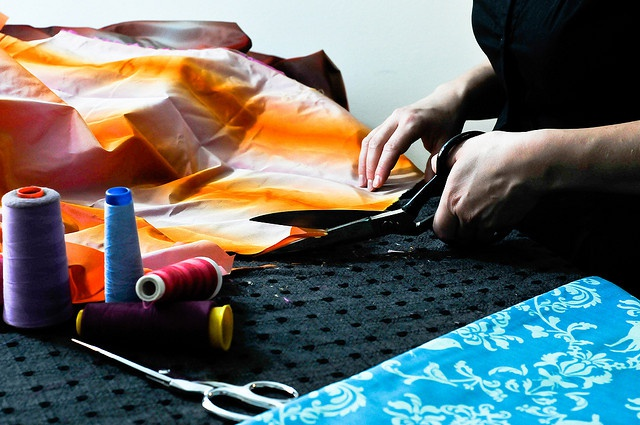Describe the objects in this image and their specific colors. I can see people in white, black, lightgray, gray, and tan tones, scissors in white, black, gray, and darkgray tones, and scissors in white, black, lightblue, and gray tones in this image. 